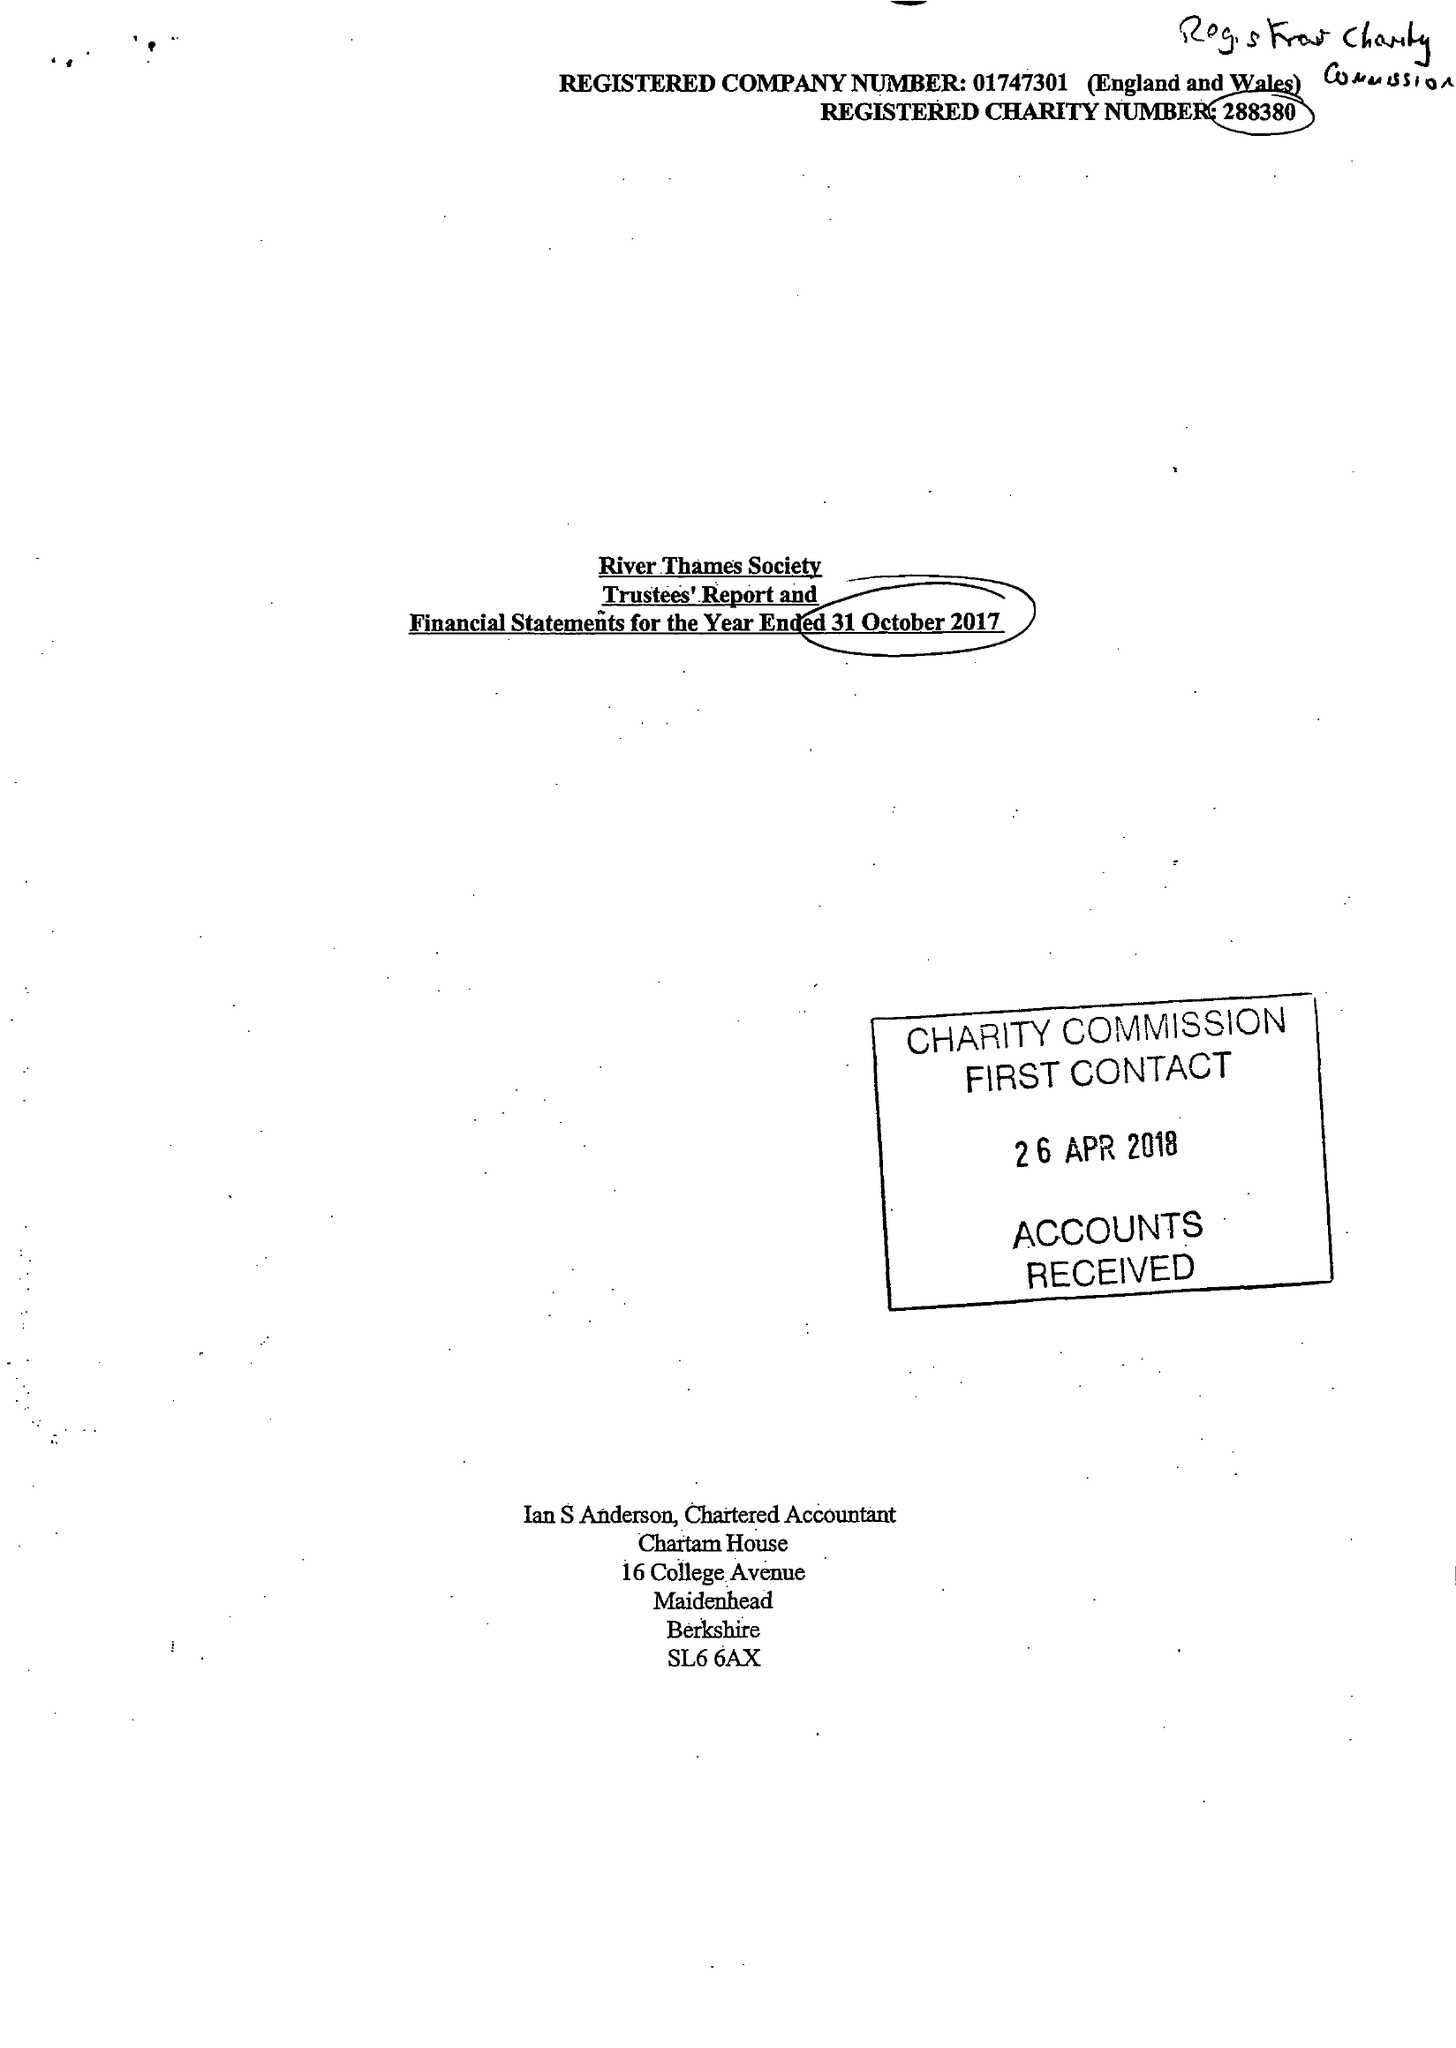What is the value for the address__street_line?
Answer the question using a single word or phrase. 28 BEAUMONT ROAD 